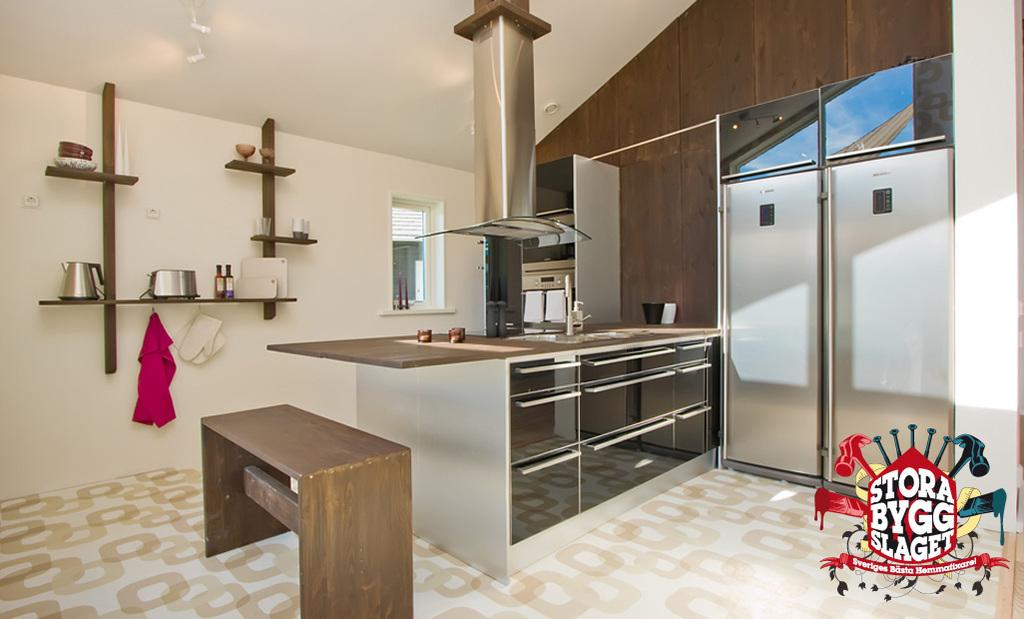What type of setting is depicted in the image? There is a kitchen set up in the image. Where are the utensils located in the image? The utensils are placed on a shelf at the left side. What type of storage units are present in the image? There are drawers in the image. What can be seen in the background of the image? There is a window in the backdrop of the image. What type of yarn is being used by the grandmother in the image? There is no grandmother or yarn present in the image. 